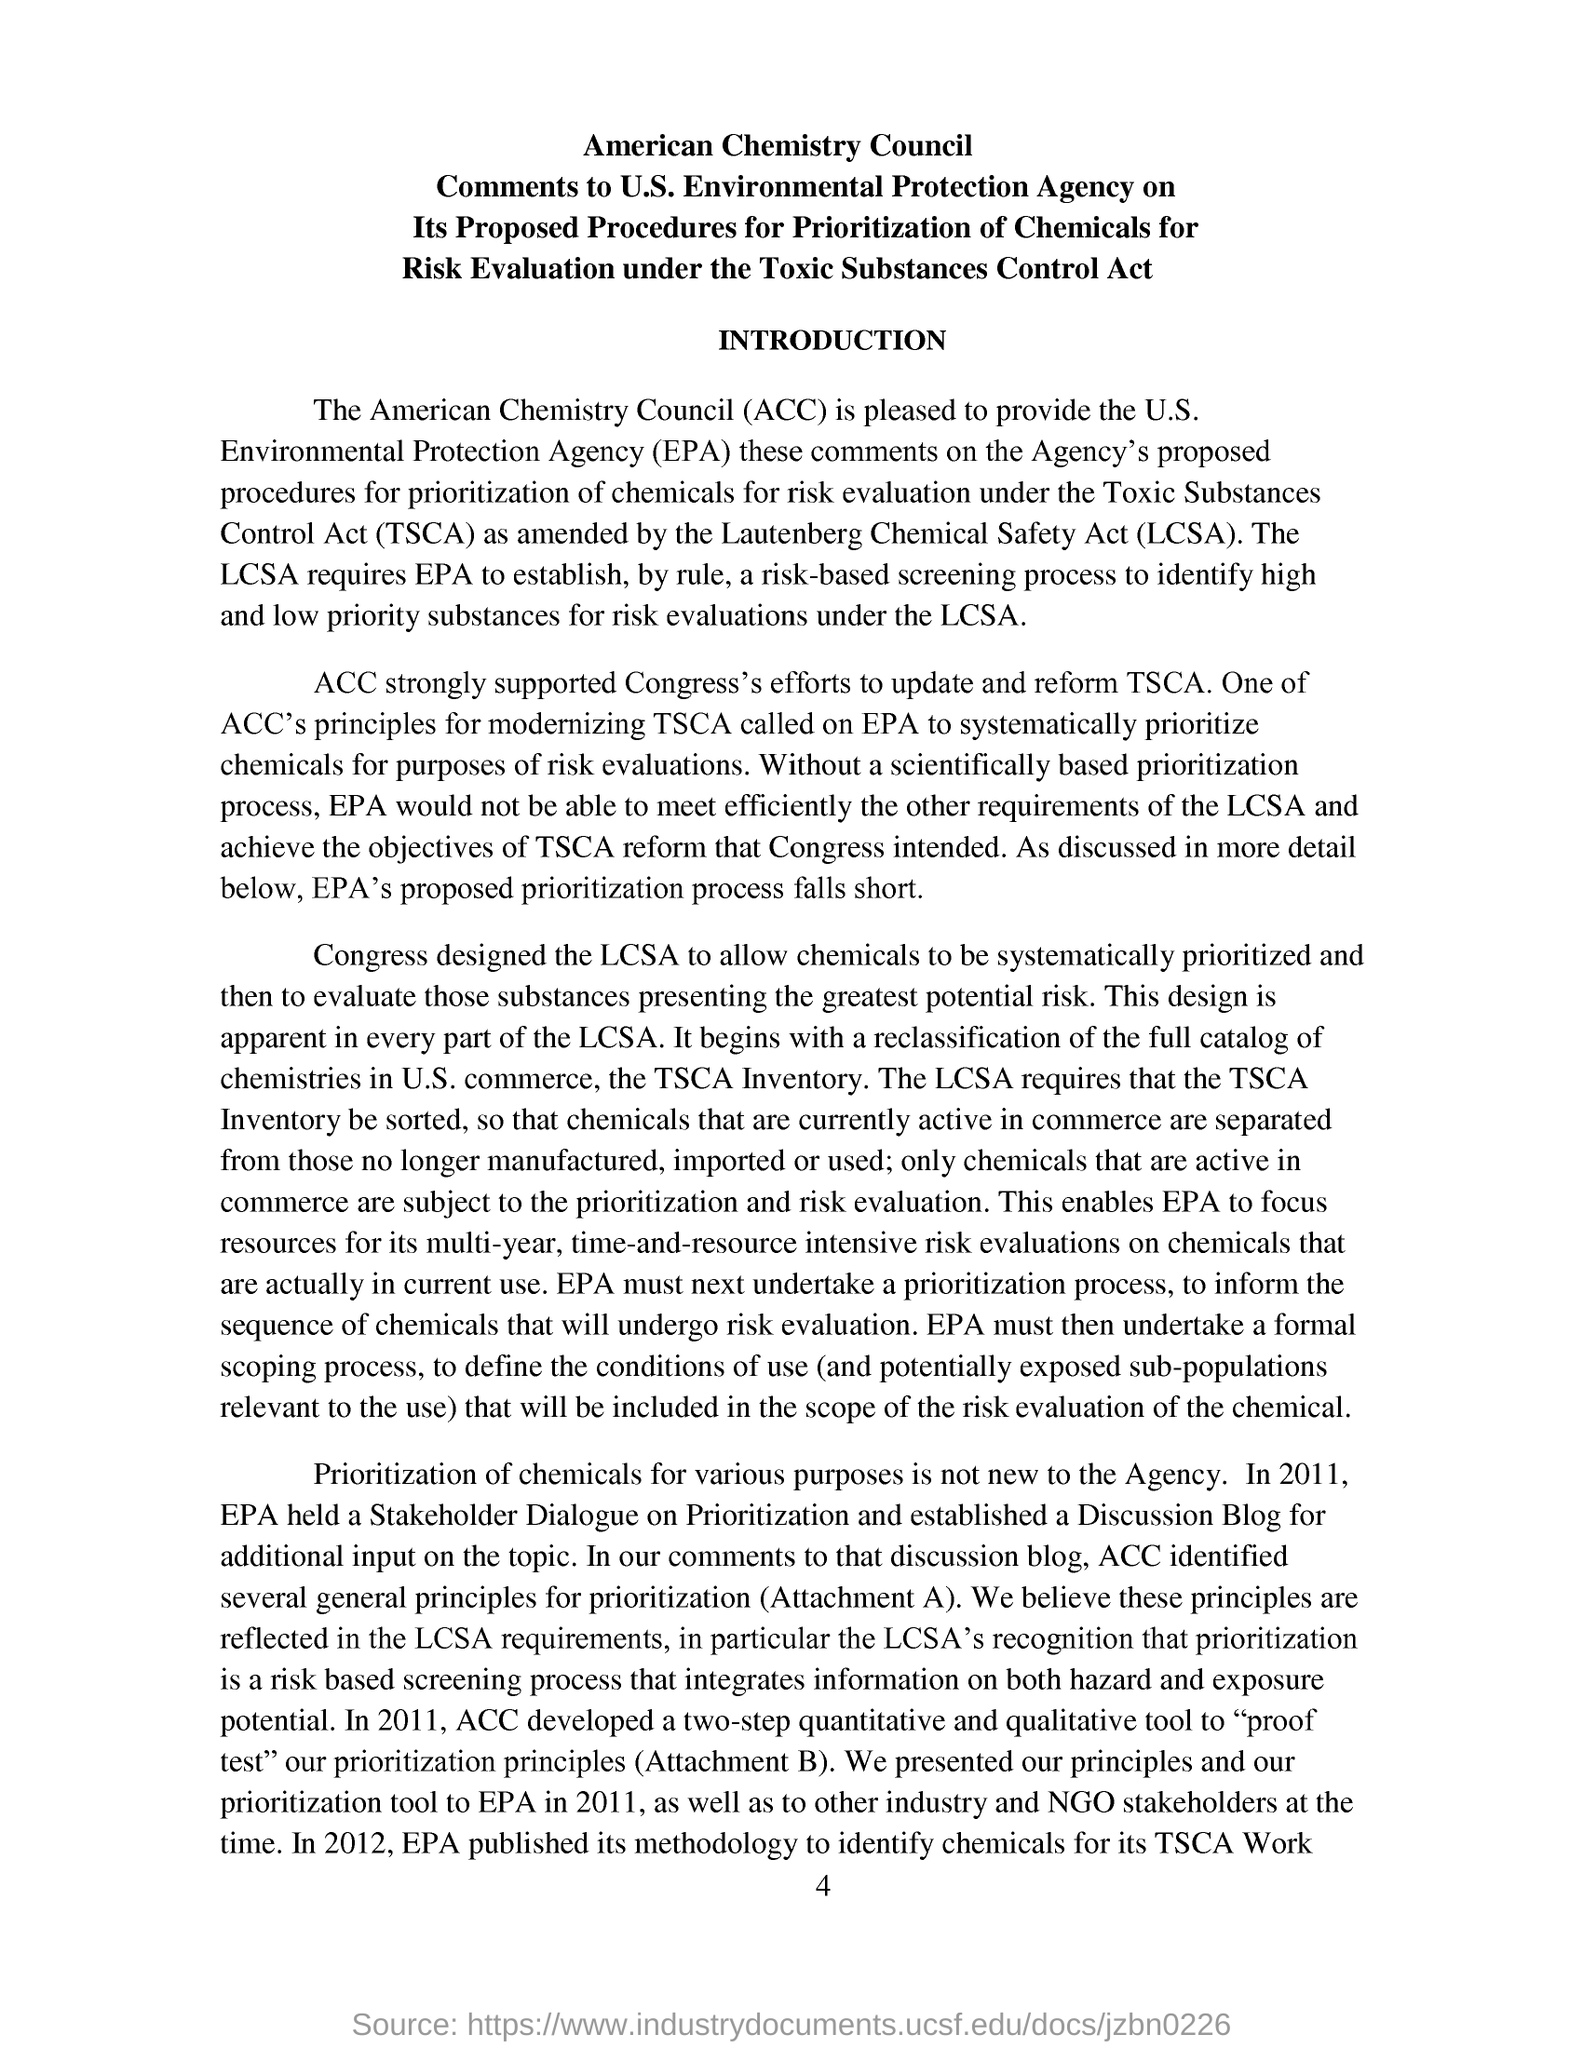What is the abbreviation of Toxic Substances Control Act?
 TSCA 